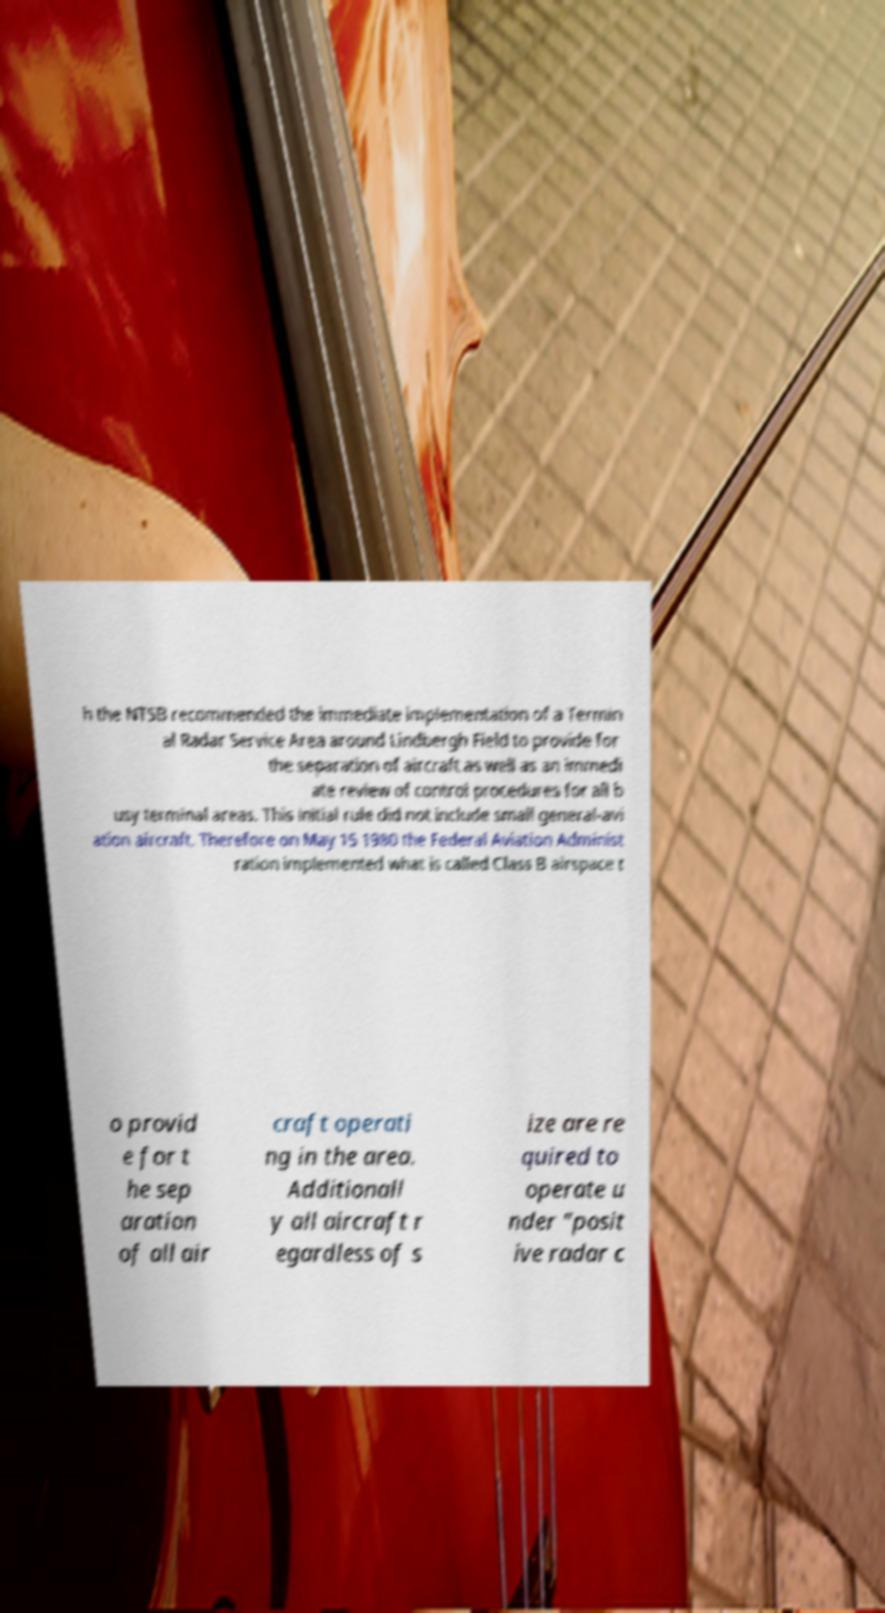Could you assist in decoding the text presented in this image and type it out clearly? h the NTSB recommended the immediate implementation of a Termin al Radar Service Area around Lindbergh Field to provide for the separation of aircraft as well as an immedi ate review of control procedures for all b usy terminal areas. This initial rule did not include small general-avi ation aircraft. Therefore on May 15 1980 the Federal Aviation Administ ration implemented what is called Class B airspace t o provid e for t he sep aration of all air craft operati ng in the area. Additionall y all aircraft r egardless of s ize are re quired to operate u nder "posit ive radar c 